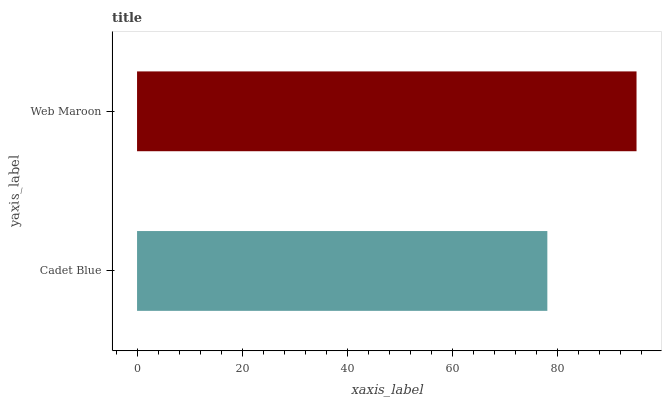Is Cadet Blue the minimum?
Answer yes or no. Yes. Is Web Maroon the maximum?
Answer yes or no. Yes. Is Web Maroon the minimum?
Answer yes or no. No. Is Web Maroon greater than Cadet Blue?
Answer yes or no. Yes. Is Cadet Blue less than Web Maroon?
Answer yes or no. Yes. Is Cadet Blue greater than Web Maroon?
Answer yes or no. No. Is Web Maroon less than Cadet Blue?
Answer yes or no. No. Is Web Maroon the high median?
Answer yes or no. Yes. Is Cadet Blue the low median?
Answer yes or no. Yes. Is Cadet Blue the high median?
Answer yes or no. No. Is Web Maroon the low median?
Answer yes or no. No. 